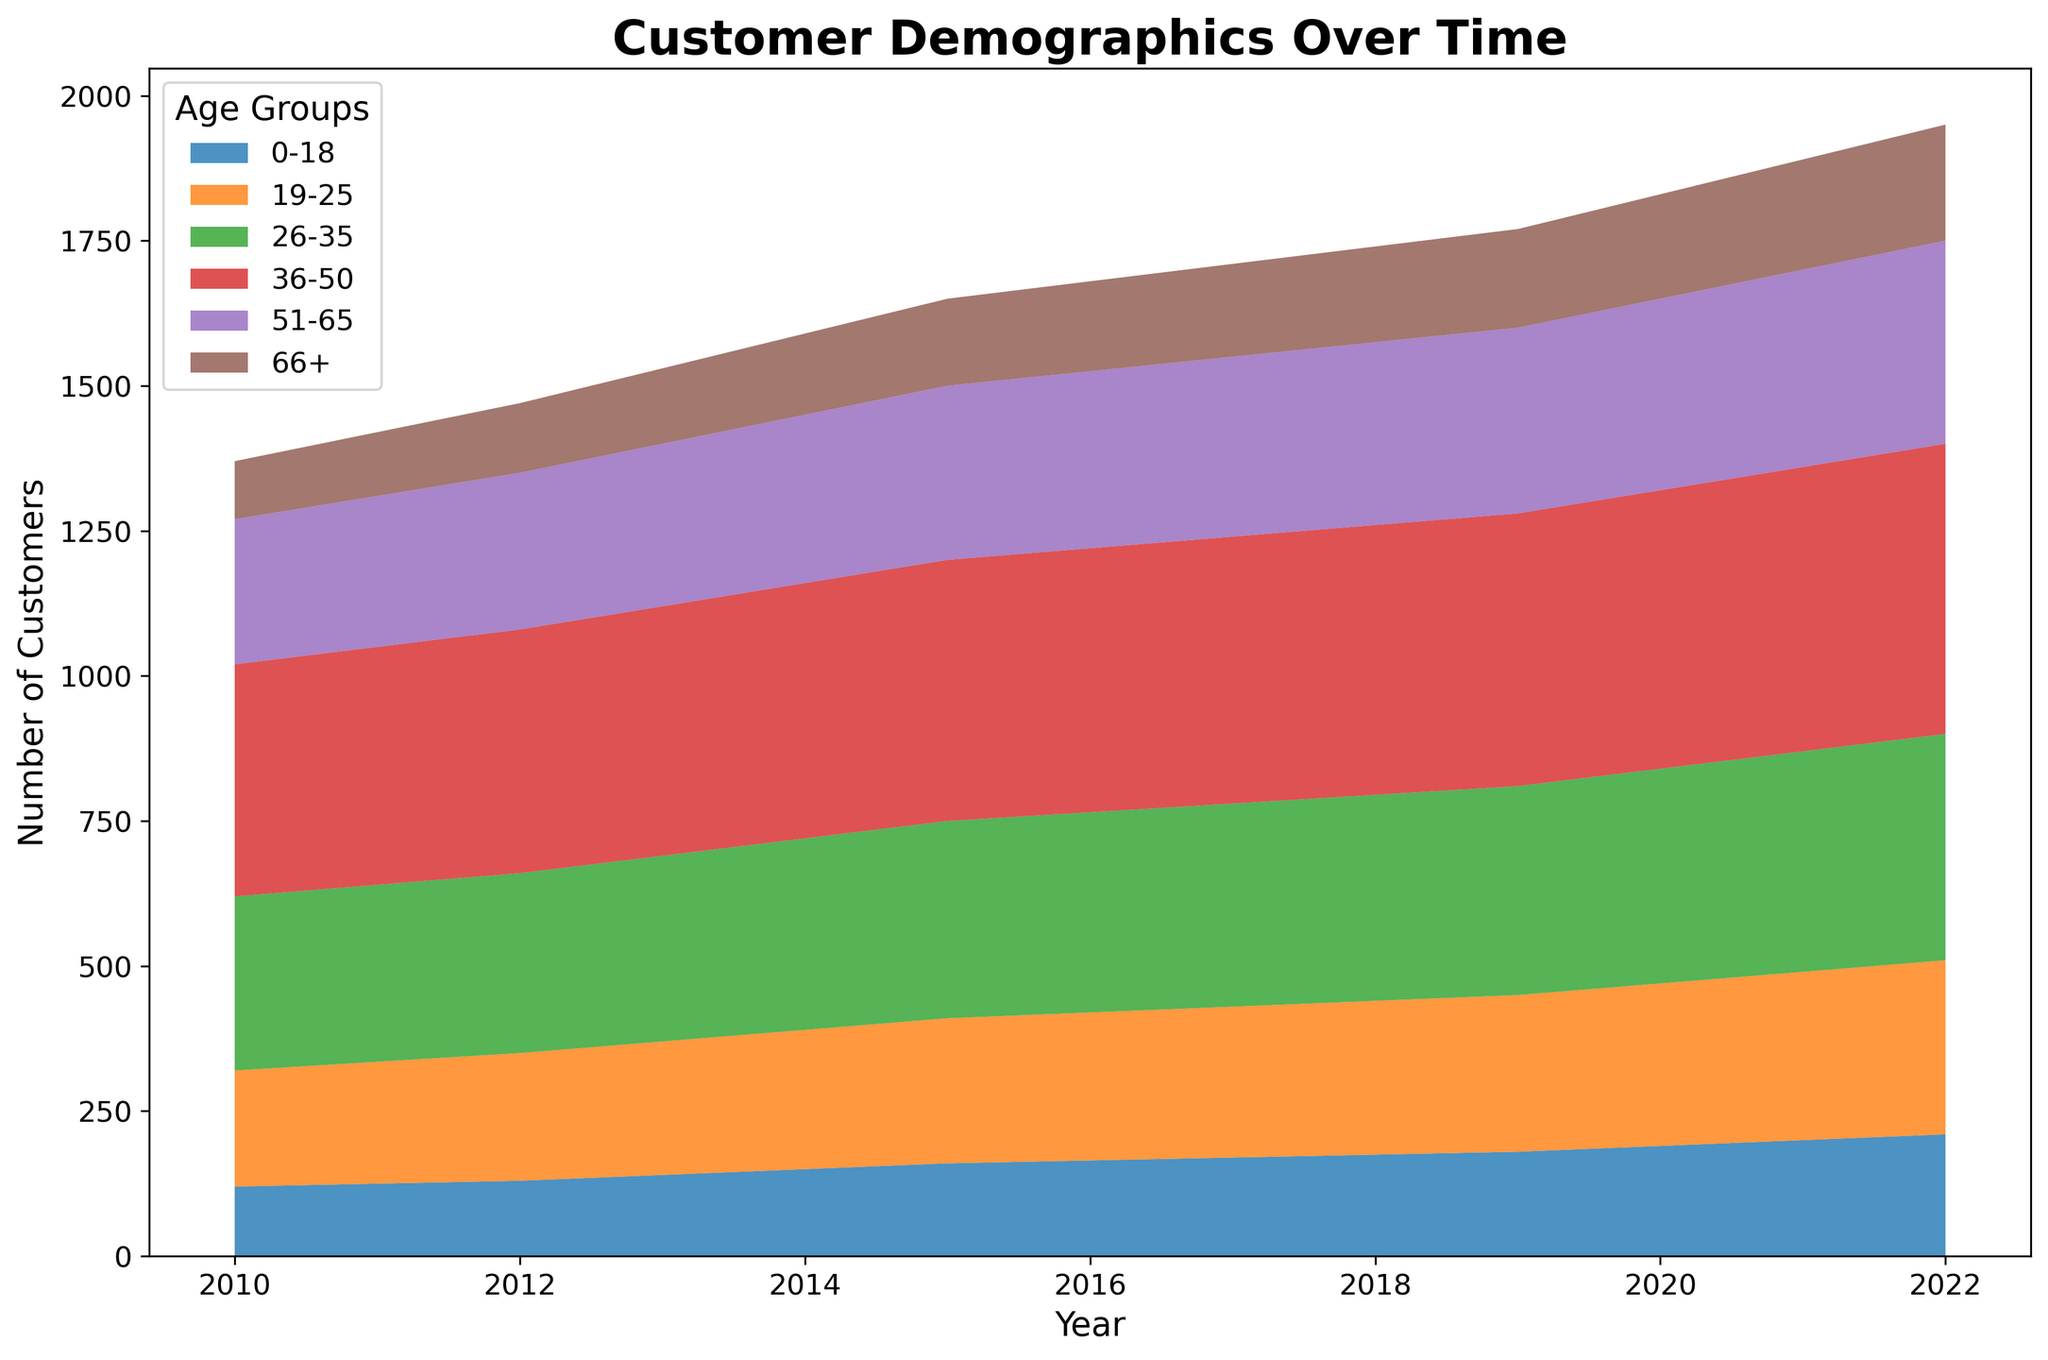How has the number of customers in the 0-18 age group changed from 2010 to 2022? To find this, look at the values for the 0-18 age group at the start and end of the timeframe. In 2010, the number is 120, and in 2022, it is 210. The change in the number of customers is 210 - 120 = 90.
Answer: Increased by 90 Which age group had the highest number of customers in 2022? To determine this, find the values for all age groups in 2022. The numbers are: 0-18: 210, 19-25: 300, 26-35: 390, 36-50: 500, 51-65: 350, and 66+: 200. The 36-50 age group has the highest value of 500.
Answer: 36-50 What is the average number of customers in the 51-65 age group over the years? Sum the values for the 51-65 age group from 2010 to 2022, then divide by the number of years (13). (250+260+270+280+290+300+305+310+315+320+330+340+350) / 13 = 3910 / 13 ≈ 300.77
Answer: 300.77 Between which pairs of consecutive years was the increase in the 19-25 age group the highest? Calculate the differences between consecutive years for the 19-25 age group: (210-200), (220-210), (230-220), (240-230), (250-240), (255-250), (260-255), (265-260), (270-265), (280-270), (290-280), (300-290). The highest increase is from 2010 to 2011, with an increase of 10.
Answer: 2010-2011 Which age group showed the most consistent increase over the years? Look for the age group with steady increases each year. All age groups increase, but to find the most consistent one, consider the one with the smallest variations in their annual increment. The 66+ group shows a steady increase of 10 each year without variations.
Answer: 66+ Which three age groups together make up the majority of customers in any given year? Visually, the largest areas represent the most significant proportions. Summing values in 2022 as an example: 36-50 (500), 26-35 (390), and 51-65 (350) combined is 500+390+350 = 1240. Check same for other years and find consistent majority groups.
Answer: 36-50, 26-35, 51-65 What was the number of customers in the 36-50 age group in 2016? Directly refer to the 36-50 value for the year 2016. The value is 455.
Answer: 455 What is the total number of customers added across all age groups from 2010 to 2022? Sum the total number of customers for each year and calculate the difference from 2010 to 2022. Sum for 2010 = 120+200+300+400+250+100=1370 and Sum for 2022 = 210+300+390+500+350+200=1950. Difference = 1950 - 1370 = 580.
Answer: 580 